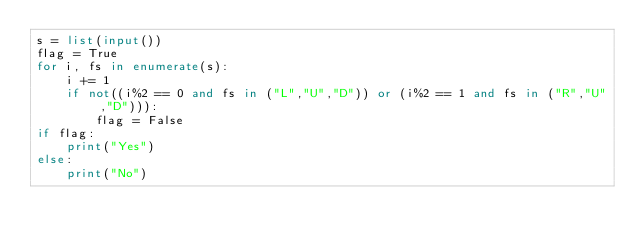<code> <loc_0><loc_0><loc_500><loc_500><_Python_>s = list(input())
flag = True
for i, fs in enumerate(s):
    i += 1
    if not((i%2 == 0 and fs in ("L","U","D")) or (i%2 == 1 and fs in ("R","U","D"))):
        flag = False
if flag:
    print("Yes")
else:
    print("No")</code> 